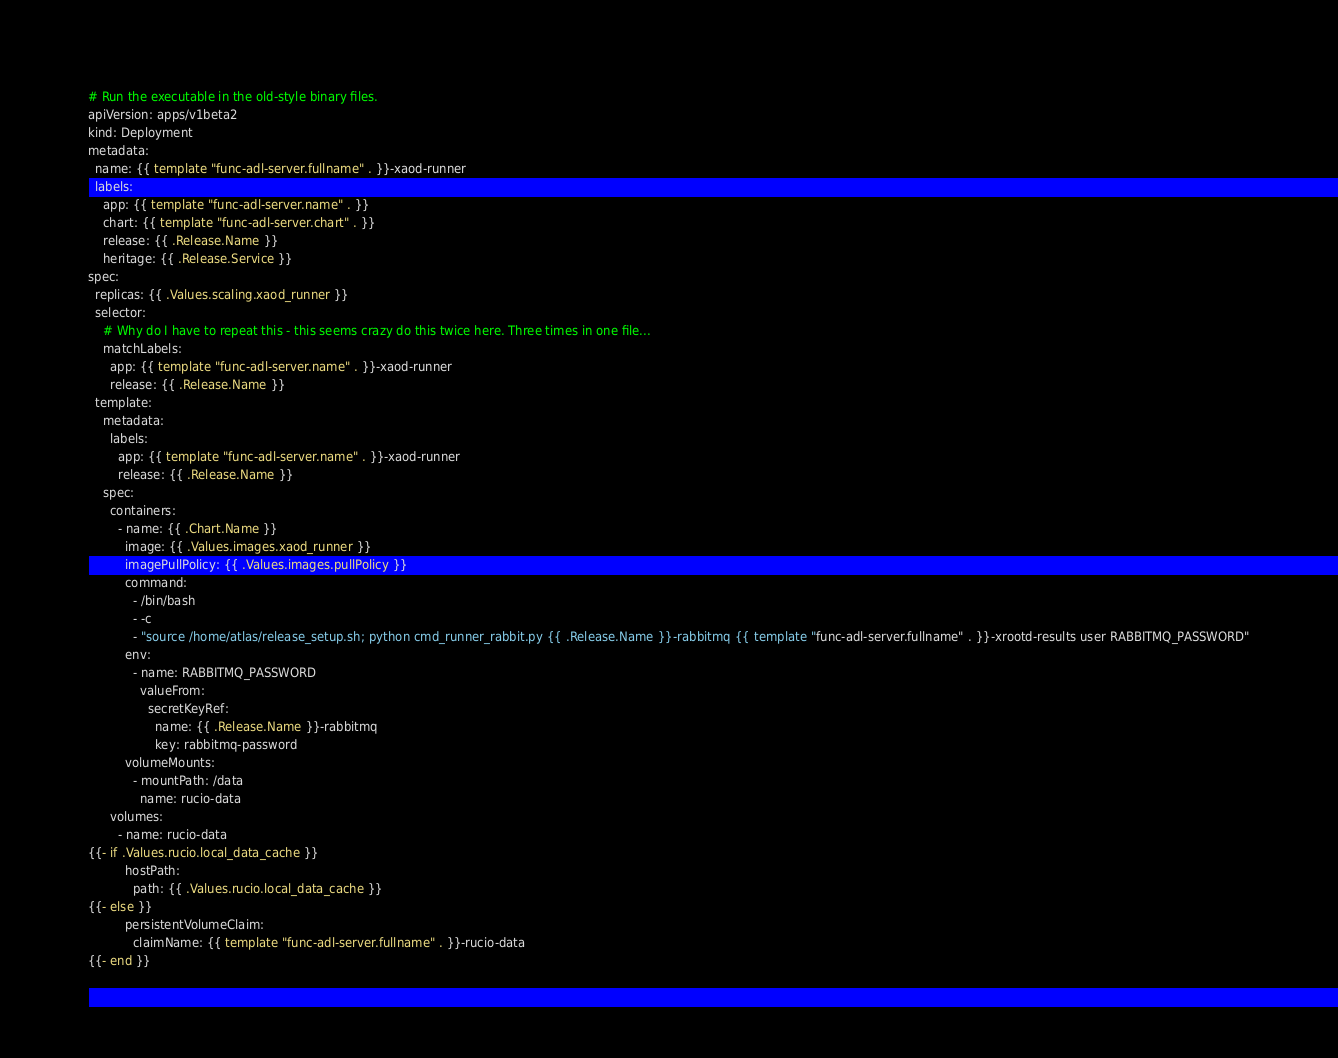Convert code to text. <code><loc_0><loc_0><loc_500><loc_500><_YAML_># Run the executable in the old-style binary files.
apiVersion: apps/v1beta2
kind: Deployment
metadata:
  name: {{ template "func-adl-server.fullname" . }}-xaod-runner
  labels:
    app: {{ template "func-adl-server.name" . }}
    chart: {{ template "func-adl-server.chart" . }}
    release: {{ .Release.Name }}
    heritage: {{ .Release.Service }}
spec:
  replicas: {{ .Values.scaling.xaod_runner }}
  selector:
    # Why do I have to repeat this - this seems crazy do this twice here. Three times in one file...
    matchLabels:
      app: {{ template "func-adl-server.name" . }}-xaod-runner
      release: {{ .Release.Name }}
  template:
    metadata:
      labels:
        app: {{ template "func-adl-server.name" . }}-xaod-runner
        release: {{ .Release.Name }}
    spec:
      containers:
        - name: {{ .Chart.Name }}
          image: {{ .Values.images.xaod_runner }}
          imagePullPolicy: {{ .Values.images.pullPolicy }}
          command:
            - /bin/bash
            - -c 
            - "source /home/atlas/release_setup.sh; python cmd_runner_rabbit.py {{ .Release.Name }}-rabbitmq {{ template "func-adl-server.fullname" . }}-xrootd-results user RABBITMQ_PASSWORD"
          env:
            - name: RABBITMQ_PASSWORD
              valueFrom:
                secretKeyRef:
                  name: {{ .Release.Name }}-rabbitmq
                  key: rabbitmq-password
          volumeMounts:
            - mountPath: /data
              name: rucio-data
      volumes:
        - name: rucio-data
{{- if .Values.rucio.local_data_cache }}
          hostPath:
            path: {{ .Values.rucio.local_data_cache }}
{{- else }}
          persistentVolumeClaim:
            claimName: {{ template "func-adl-server.fullname" . }}-rucio-data
{{- end }}
</code> 